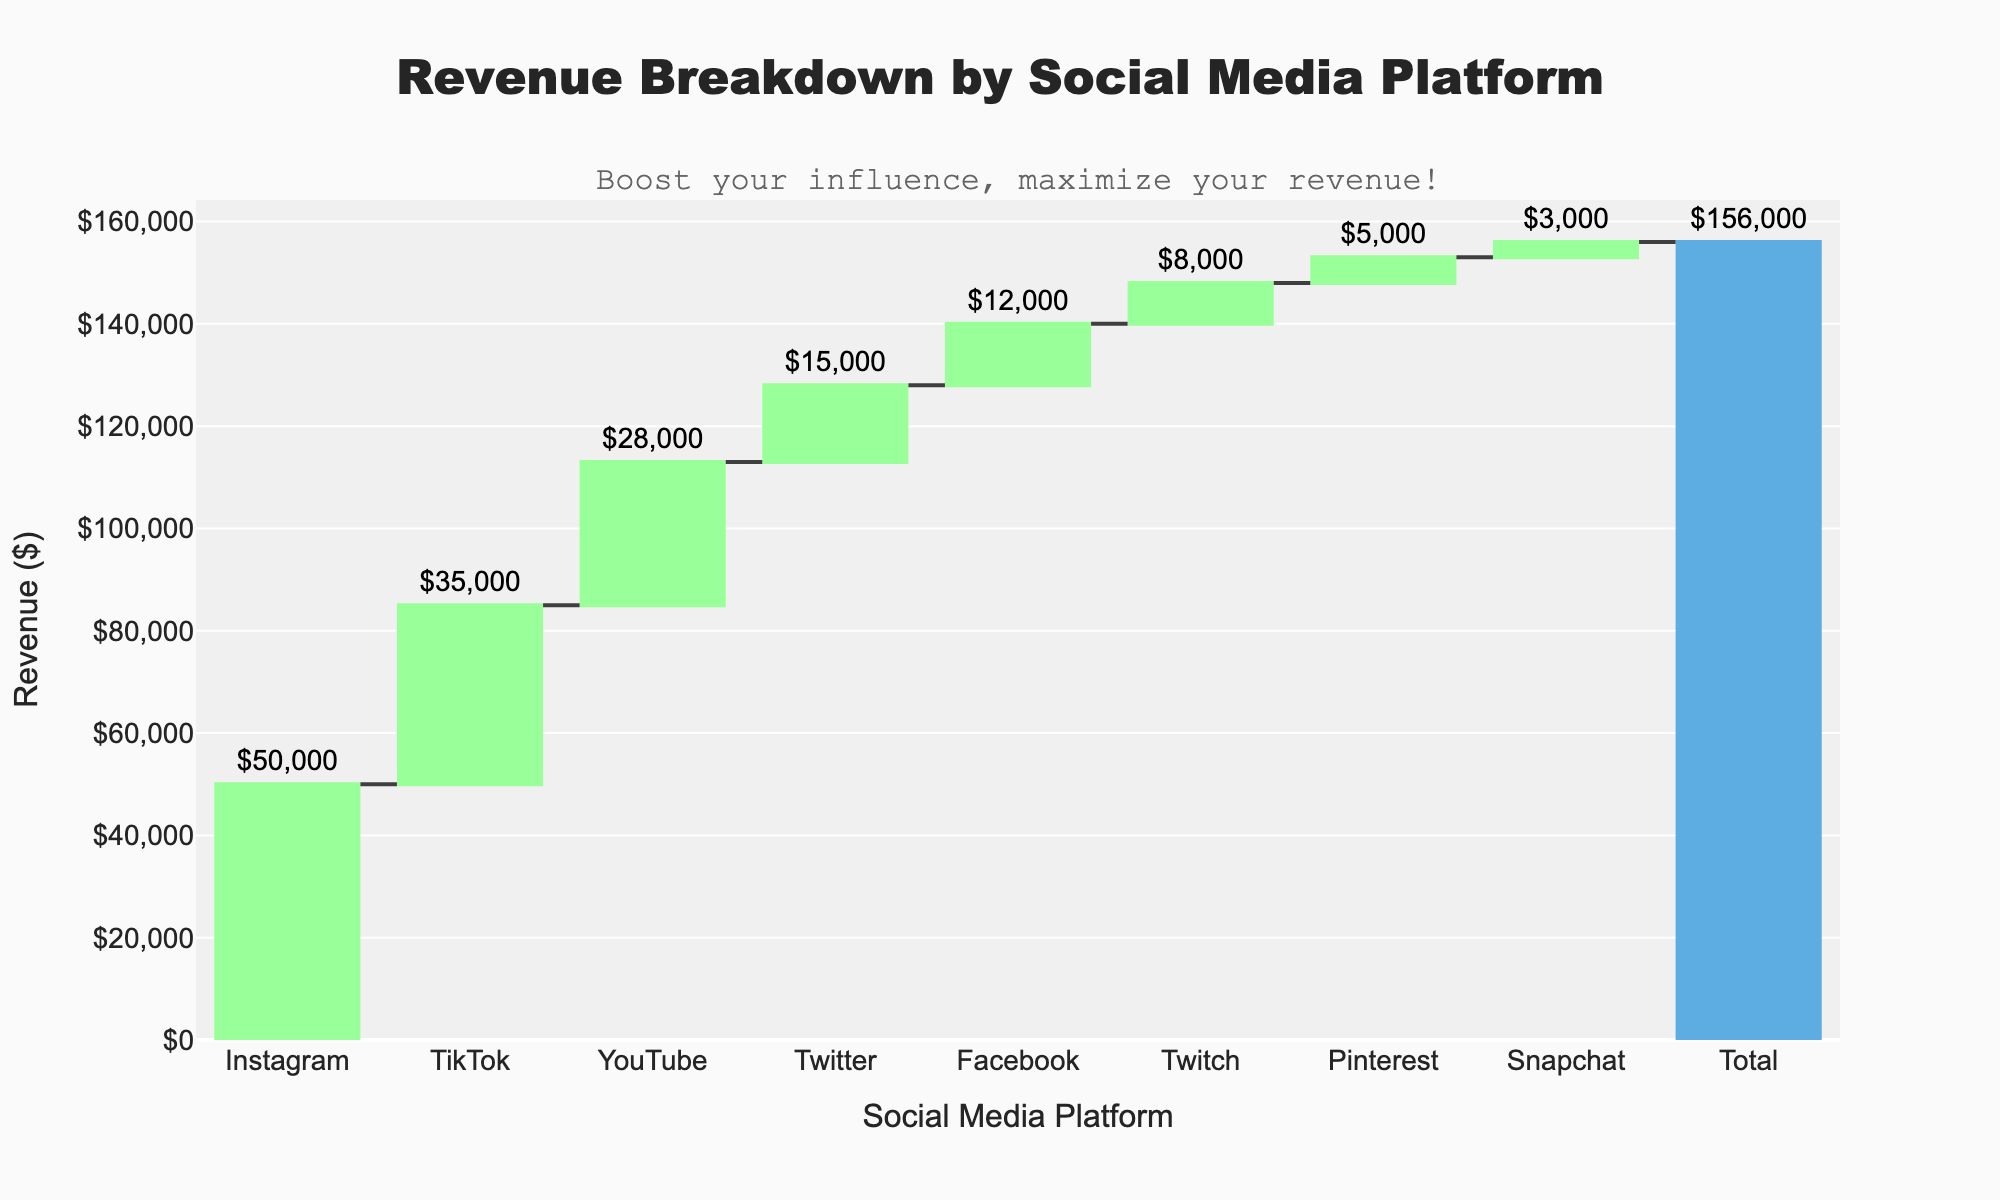How much revenue does Instagram generate? We can directly read the revenue for Instagram from the chart, which is positioned at the top.
Answer: $50,000 What is the total revenue from all platforms combined? The total revenue is explicitly labeled at the end of the chart.
Answer: $156,000 How much more revenue did TikTok generate compared to Twitch? To find this, subtract Twitch's revenue from TikTok's revenue (35,000 - 8,000).
Answer: $27,000 Which platform contributed the least to the total revenue? Identify the platform with the shortest bar in the chart, which is labeled as Snapchat.
Answer: Snapchat Order the platforms by their revenue contributions from highest to lowest. Observe the heights of the bars and list them from tallest to shortest: Instagram, TikTok, YouTube, Twitter, Facebook, Twitch, Pinterest, Snapchat.
Answer: Instagram, TikTok, YouTube, Twitter, Facebook, Twitch, Pinterest, Snapchat What is the combined revenue generated by YouTube and Twitter? Add the revenue values for YouTube and Twitter (28,000 + 15,000).
Answer: $43,000 Which platform had the smallest revenue increase relative to its predecessor? Look at the heights of the increment bars between consecutive platforms and identify the smallest: Pinterest to Snapchat has the smallest increase.
Answer: Pinterest to Snapchat Does Facebook generate more or less revenue than YouTube? Compare the heights of the bars for Facebook and YouTube: YouTube's bar is taller.
Answer: Less What percentage of the total revenue is generated by Instagram? Divide Instagram's revenue by the total revenue and multiply by 100 (50,000 / 156,000 * 100).
Answer: Approximately 32.1% How many social media platforms are included in the chart? Count the number of bars representing platforms: Instagram, TikTok, YouTube, Twitter, Facebook, Twitch, Pinterest, Snapchat.
Answer: 8 